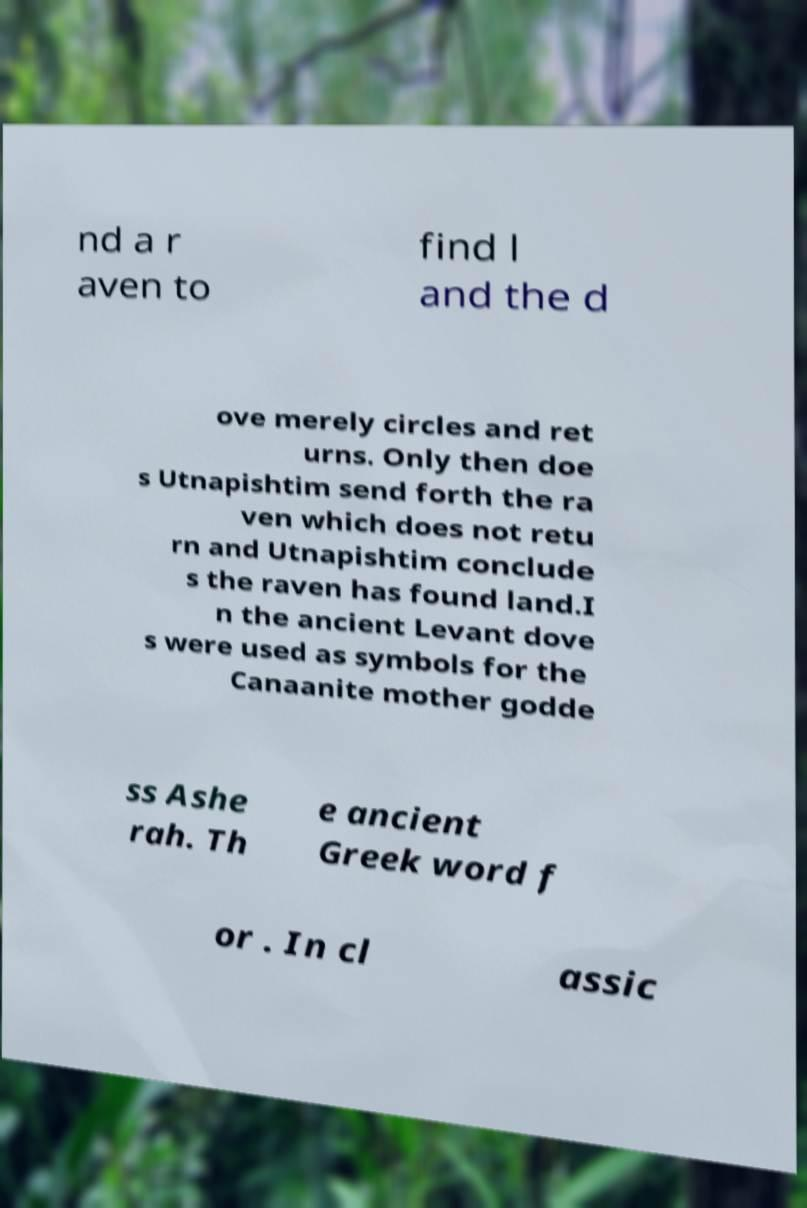Can you accurately transcribe the text from the provided image for me? nd a r aven to find l and the d ove merely circles and ret urns. Only then doe s Utnapishtim send forth the ra ven which does not retu rn and Utnapishtim conclude s the raven has found land.I n the ancient Levant dove s were used as symbols for the Canaanite mother godde ss Ashe rah. Th e ancient Greek word f or . In cl assic 